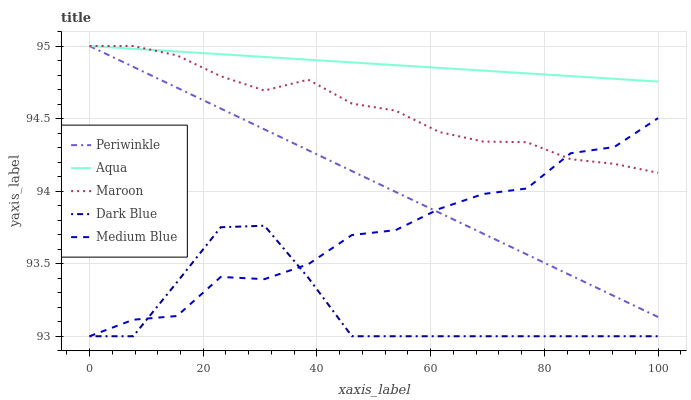Does Periwinkle have the minimum area under the curve?
Answer yes or no. No. Does Periwinkle have the maximum area under the curve?
Answer yes or no. No. Is Medium Blue the smoothest?
Answer yes or no. No. Is Periwinkle the roughest?
Answer yes or no. No. Does Periwinkle have the lowest value?
Answer yes or no. No. Does Medium Blue have the highest value?
Answer yes or no. No. Is Dark Blue less than Maroon?
Answer yes or no. Yes. Is Aqua greater than Dark Blue?
Answer yes or no. Yes. Does Dark Blue intersect Maroon?
Answer yes or no. No. 